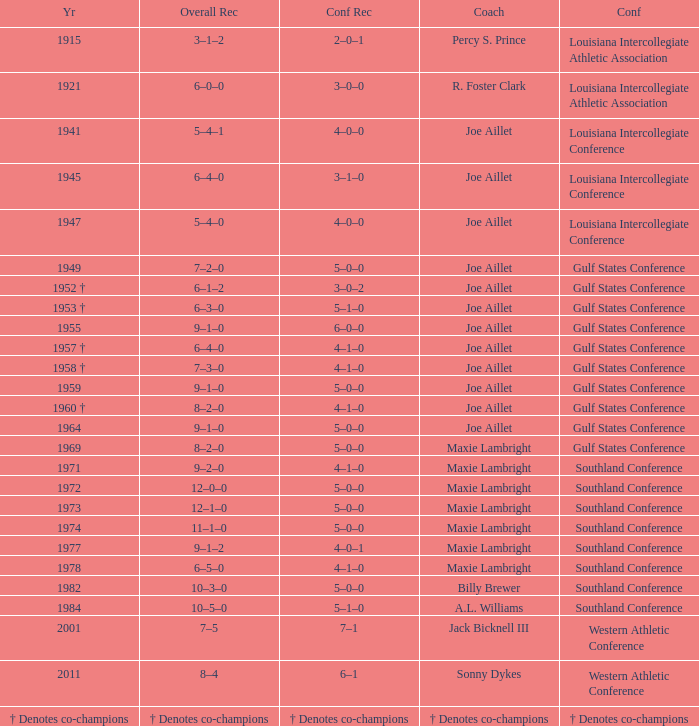What is the conference record for the year of 1971? 4–1–0. 